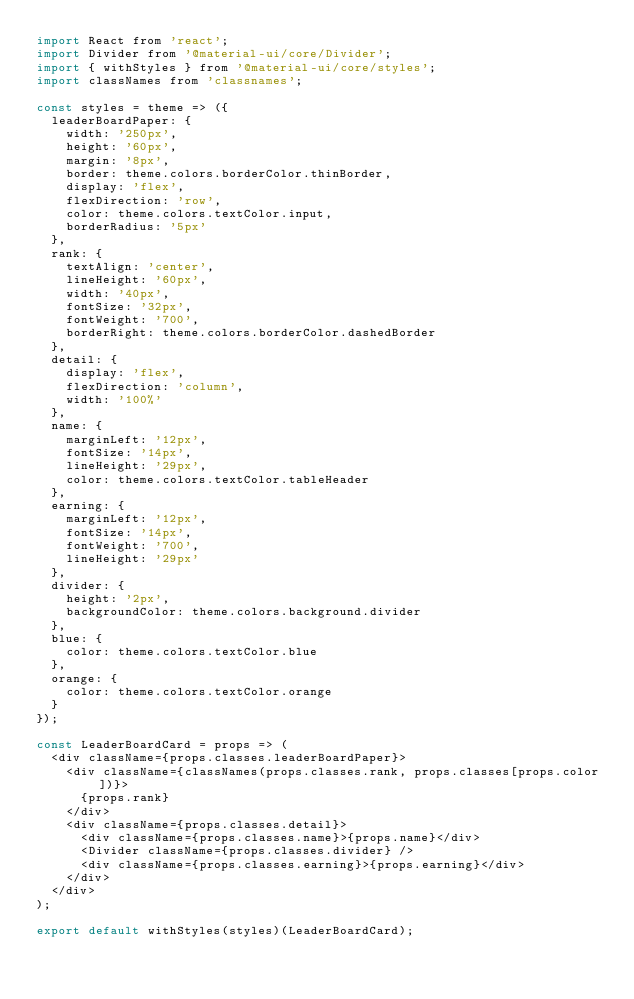<code> <loc_0><loc_0><loc_500><loc_500><_JavaScript_>import React from 'react';
import Divider from '@material-ui/core/Divider';
import { withStyles } from '@material-ui/core/styles';
import classNames from 'classnames';

const styles = theme => ({
  leaderBoardPaper: {
    width: '250px',
    height: '60px',
    margin: '8px',
    border: theme.colors.borderColor.thinBorder,
    display: 'flex',
    flexDirection: 'row',
    color: theme.colors.textColor.input,
    borderRadius: '5px'
  },
  rank: {
    textAlign: 'center',
    lineHeight: '60px',
    width: '40px',
    fontSize: '32px',
    fontWeight: '700',
    borderRight: theme.colors.borderColor.dashedBorder
  },
  detail: {
    display: 'flex',
    flexDirection: 'column',
    width: '100%'
  },
  name: {
    marginLeft: '12px',
    fontSize: '14px',
    lineHeight: '29px',
    color: theme.colors.textColor.tableHeader
  },
  earning: {
    marginLeft: '12px',
    fontSize: '14px',
    fontWeight: '700',
    lineHeight: '29px'
  },
  divider: {
    height: '2px',
    backgroundColor: theme.colors.background.divider
  },
  blue: {
    color: theme.colors.textColor.blue
  },
  orange: {
    color: theme.colors.textColor.orange
  }
});

const LeaderBoardCard = props => (
  <div className={props.classes.leaderBoardPaper}>
    <div className={classNames(props.classes.rank, props.classes[props.color])}>
      {props.rank}
    </div>
    <div className={props.classes.detail}>
      <div className={props.classes.name}>{props.name}</div>
      <Divider className={props.classes.divider} />
      <div className={props.classes.earning}>{props.earning}</div>
    </div>
  </div>
);

export default withStyles(styles)(LeaderBoardCard);
</code> 